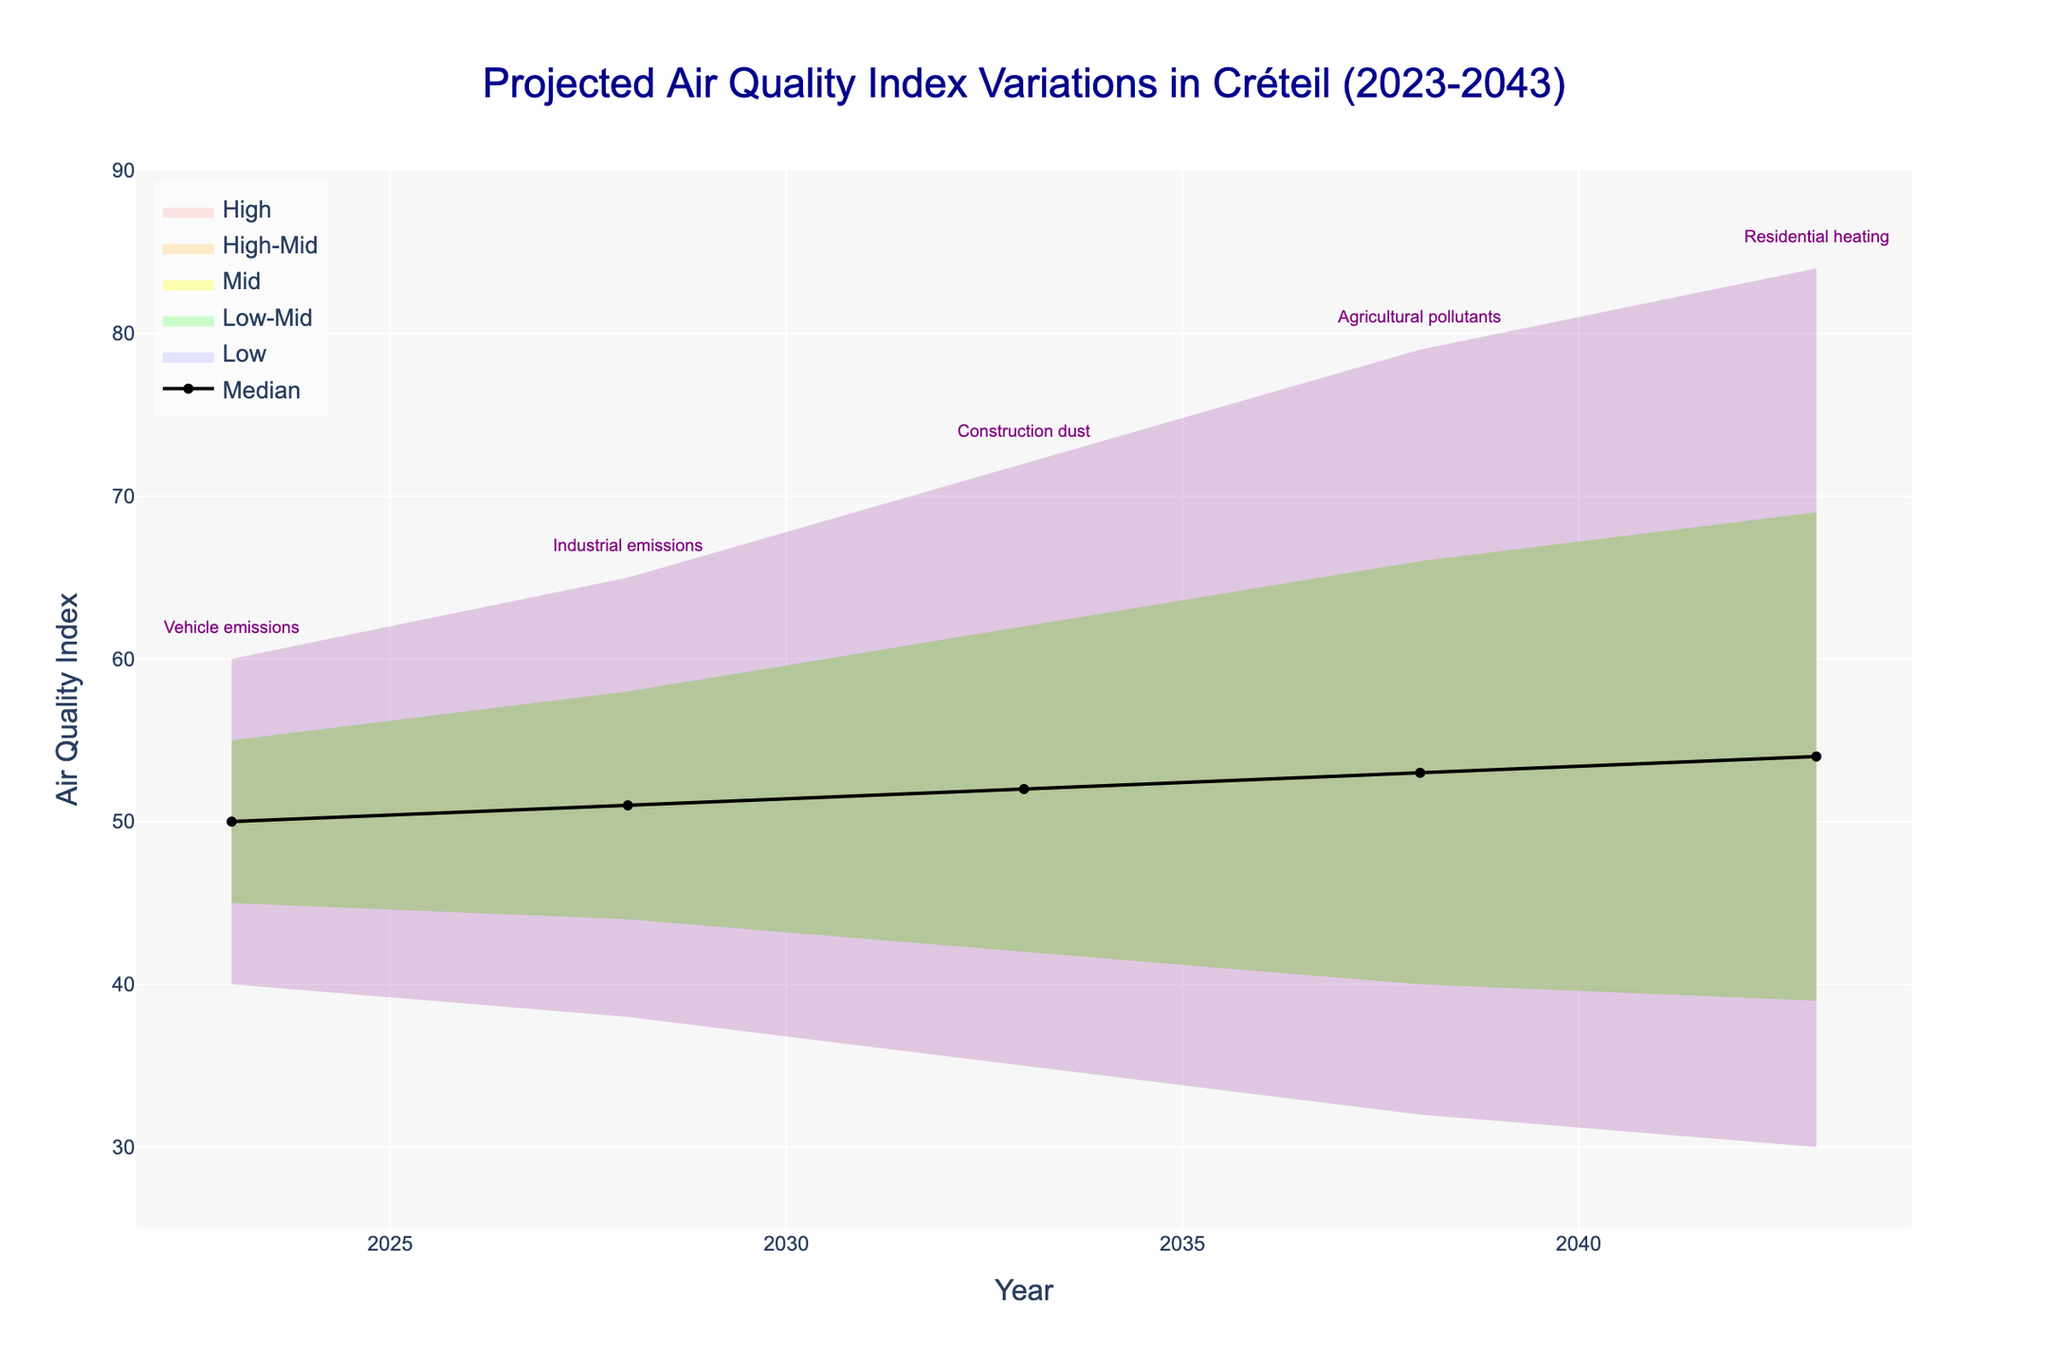What is the title of this figure? The title is displayed at the top of the figure and usually describes the main topic or data being visualized. In this case, it tells us about the projected air quality index variations in Créteil from 2023 to 2043.
Answer: Projected Air Quality Index Variations in Créteil (2023-2043) What are the years covered in this figure? The years covered in the figure can be seen from the x-axis labels running from the start to the end of the timeline displayed.
Answer: 2023, 2028, 2033, 2038, 2043 What is the median Air Quality Index (AQI) projection for 2038? The median AQI projection for a specific year can be read from the 'Median' trace, which is the black line in the middle of the fan chart. For the year 2038, you can find this value directly on the graph.
Answer: 53 What year shows the highest variability in projected AQI levels? Variability in the AQI levels can be determined by the range between 'Low' and 'High' projections for each year. The year with the widest band between these values indicates the highest variability.
Answer: 2043 Which year has the lowest projected AQI 'Low' value? The 'Low' values are depicted by the innermost (blue-colored) region of the fan for each year. We look at the values listed or shown in this part for each year to find the lowest one.
Answer: 2043 What is the main pollution source affecting the AQI in 2028? The main pollution source is given in the annotations above the figure for each corresponding year. By locating the annotation for the year 2028, we can determine its main pollution source.
Answer: Industrial emissions How does the AQI 'High' value progress from 2023 to 2043? By following the 'High' values, which are depicted in the outermost (red-colored) region of the fan trace from 2023 to 2043, we can observe whether it increases, decreases, or remains stable. We need to list the values and observe the trend. The 'High' values go from 60 in 2023, to 65 in 2028, to 72 in 2033, to 79 in 2038, and finally to 84 in 2043, showing a gradual increase.
Answer: Gradually increases What is the difference between the 'Low-Mid' and 'High-Mid' AQI projections in 2043? The 'Low-Mid' and 'High-Mid' projections are labeled on the chart, with the difference calculated by subtracting the 'Low-Mid' value from the 'High-Mid' value for the year 2043.
Answer: 30 How many distinct colors are used to represent different AQI projection levels in this figure? By visually inspecting the figure, we can identify the different shades of color used to depict various AQI projection levels ('Low', 'Low-Mid', 'Mid', 'High-Mid', 'High').
Answer: 5 Which pollution source is predicted to have the greatest impact on AQI variability over the 20 years? To determine the pollution source with the greatest impact on AQI variability, one can look at the width of the bands and note the corresponding pollution sources over the years. The projected AQI in 2043, with residential heating as the pollution source, shows the largest variability.
Answer: Residential heating 